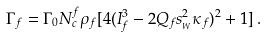Convert formula to latex. <formula><loc_0><loc_0><loc_500><loc_500>\Gamma _ { f } = \Gamma _ { 0 } N _ { c } ^ { f } \rho _ { f } [ 4 ( I ^ { 3 } _ { f } - 2 Q _ { f } s _ { _ { W } } ^ { 2 } \kappa _ { f } ) ^ { 2 } + 1 ] \, .</formula> 